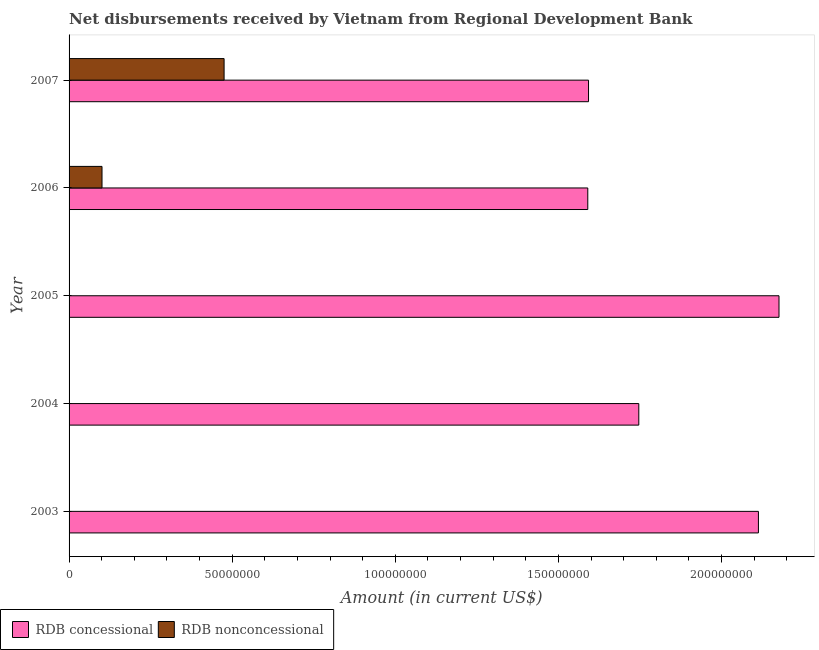How many bars are there on the 1st tick from the bottom?
Your response must be concise. 1. In how many cases, is the number of bars for a given year not equal to the number of legend labels?
Give a very brief answer. 3. What is the net concessional disbursements from rdb in 2003?
Provide a succinct answer. 2.11e+08. Across all years, what is the maximum net non concessional disbursements from rdb?
Make the answer very short. 4.75e+07. Across all years, what is the minimum net concessional disbursements from rdb?
Provide a short and direct response. 1.59e+08. In which year was the net non concessional disbursements from rdb maximum?
Your answer should be compact. 2007. What is the total net non concessional disbursements from rdb in the graph?
Make the answer very short. 5.76e+07. What is the difference between the net concessional disbursements from rdb in 2004 and that in 2007?
Make the answer very short. 1.54e+07. What is the difference between the net non concessional disbursements from rdb in 2005 and the net concessional disbursements from rdb in 2007?
Your response must be concise. -1.59e+08. What is the average net concessional disbursements from rdb per year?
Provide a succinct answer. 1.84e+08. In the year 2006, what is the difference between the net concessional disbursements from rdb and net non concessional disbursements from rdb?
Make the answer very short. 1.49e+08. What is the ratio of the net non concessional disbursements from rdb in 2006 to that in 2007?
Your answer should be very brief. 0.21. Is the net concessional disbursements from rdb in 2003 less than that in 2006?
Your answer should be compact. No. What is the difference between the highest and the second highest net concessional disbursements from rdb?
Provide a succinct answer. 6.31e+06. What is the difference between the highest and the lowest net non concessional disbursements from rdb?
Keep it short and to the point. 4.75e+07. In how many years, is the net non concessional disbursements from rdb greater than the average net non concessional disbursements from rdb taken over all years?
Give a very brief answer. 1. Is the sum of the net concessional disbursements from rdb in 2004 and 2005 greater than the maximum net non concessional disbursements from rdb across all years?
Your answer should be compact. Yes. How many bars are there?
Provide a succinct answer. 7. Are all the bars in the graph horizontal?
Offer a very short reply. Yes. Does the graph contain grids?
Your response must be concise. No. How are the legend labels stacked?
Your answer should be very brief. Horizontal. What is the title of the graph?
Provide a succinct answer. Net disbursements received by Vietnam from Regional Development Bank. Does "Nonresident" appear as one of the legend labels in the graph?
Provide a succinct answer. No. What is the label or title of the X-axis?
Provide a succinct answer. Amount (in current US$). What is the Amount (in current US$) of RDB concessional in 2003?
Offer a terse response. 2.11e+08. What is the Amount (in current US$) of RDB nonconcessional in 2003?
Your answer should be compact. 0. What is the Amount (in current US$) in RDB concessional in 2004?
Ensure brevity in your answer.  1.75e+08. What is the Amount (in current US$) of RDB nonconcessional in 2004?
Make the answer very short. 0. What is the Amount (in current US$) of RDB concessional in 2005?
Your answer should be very brief. 2.18e+08. What is the Amount (in current US$) in RDB concessional in 2006?
Your answer should be very brief. 1.59e+08. What is the Amount (in current US$) of RDB nonconcessional in 2006?
Provide a succinct answer. 1.01e+07. What is the Amount (in current US$) in RDB concessional in 2007?
Make the answer very short. 1.59e+08. What is the Amount (in current US$) of RDB nonconcessional in 2007?
Provide a short and direct response. 4.75e+07. Across all years, what is the maximum Amount (in current US$) in RDB concessional?
Give a very brief answer. 2.18e+08. Across all years, what is the maximum Amount (in current US$) of RDB nonconcessional?
Provide a succinct answer. 4.75e+07. Across all years, what is the minimum Amount (in current US$) of RDB concessional?
Offer a very short reply. 1.59e+08. Across all years, what is the minimum Amount (in current US$) in RDB nonconcessional?
Keep it short and to the point. 0. What is the total Amount (in current US$) of RDB concessional in the graph?
Provide a short and direct response. 9.22e+08. What is the total Amount (in current US$) in RDB nonconcessional in the graph?
Offer a terse response. 5.76e+07. What is the difference between the Amount (in current US$) in RDB concessional in 2003 and that in 2004?
Your answer should be compact. 3.67e+07. What is the difference between the Amount (in current US$) of RDB concessional in 2003 and that in 2005?
Offer a very short reply. -6.31e+06. What is the difference between the Amount (in current US$) in RDB concessional in 2003 and that in 2006?
Offer a terse response. 5.23e+07. What is the difference between the Amount (in current US$) of RDB concessional in 2003 and that in 2007?
Keep it short and to the point. 5.21e+07. What is the difference between the Amount (in current US$) of RDB concessional in 2004 and that in 2005?
Make the answer very short. -4.30e+07. What is the difference between the Amount (in current US$) in RDB concessional in 2004 and that in 2006?
Ensure brevity in your answer.  1.56e+07. What is the difference between the Amount (in current US$) in RDB concessional in 2004 and that in 2007?
Provide a succinct answer. 1.54e+07. What is the difference between the Amount (in current US$) of RDB concessional in 2005 and that in 2006?
Your answer should be compact. 5.86e+07. What is the difference between the Amount (in current US$) in RDB concessional in 2005 and that in 2007?
Provide a succinct answer. 5.84e+07. What is the difference between the Amount (in current US$) of RDB concessional in 2006 and that in 2007?
Your response must be concise. -2.31e+05. What is the difference between the Amount (in current US$) in RDB nonconcessional in 2006 and that in 2007?
Give a very brief answer. -3.74e+07. What is the difference between the Amount (in current US$) in RDB concessional in 2003 and the Amount (in current US$) in RDB nonconcessional in 2006?
Provide a succinct answer. 2.01e+08. What is the difference between the Amount (in current US$) in RDB concessional in 2003 and the Amount (in current US$) in RDB nonconcessional in 2007?
Provide a succinct answer. 1.64e+08. What is the difference between the Amount (in current US$) in RDB concessional in 2004 and the Amount (in current US$) in RDB nonconcessional in 2006?
Your answer should be very brief. 1.65e+08. What is the difference between the Amount (in current US$) of RDB concessional in 2004 and the Amount (in current US$) of RDB nonconcessional in 2007?
Offer a very short reply. 1.27e+08. What is the difference between the Amount (in current US$) in RDB concessional in 2005 and the Amount (in current US$) in RDB nonconcessional in 2006?
Offer a terse response. 2.08e+08. What is the difference between the Amount (in current US$) in RDB concessional in 2005 and the Amount (in current US$) in RDB nonconcessional in 2007?
Make the answer very short. 1.70e+08. What is the difference between the Amount (in current US$) in RDB concessional in 2006 and the Amount (in current US$) in RDB nonconcessional in 2007?
Your answer should be compact. 1.11e+08. What is the average Amount (in current US$) of RDB concessional per year?
Provide a short and direct response. 1.84e+08. What is the average Amount (in current US$) in RDB nonconcessional per year?
Give a very brief answer. 1.15e+07. In the year 2006, what is the difference between the Amount (in current US$) of RDB concessional and Amount (in current US$) of RDB nonconcessional?
Provide a short and direct response. 1.49e+08. In the year 2007, what is the difference between the Amount (in current US$) of RDB concessional and Amount (in current US$) of RDB nonconcessional?
Offer a terse response. 1.12e+08. What is the ratio of the Amount (in current US$) of RDB concessional in 2003 to that in 2004?
Give a very brief answer. 1.21. What is the ratio of the Amount (in current US$) in RDB concessional in 2003 to that in 2006?
Give a very brief answer. 1.33. What is the ratio of the Amount (in current US$) of RDB concessional in 2003 to that in 2007?
Ensure brevity in your answer.  1.33. What is the ratio of the Amount (in current US$) in RDB concessional in 2004 to that in 2005?
Offer a terse response. 0.8. What is the ratio of the Amount (in current US$) of RDB concessional in 2004 to that in 2006?
Offer a very short reply. 1.1. What is the ratio of the Amount (in current US$) in RDB concessional in 2004 to that in 2007?
Keep it short and to the point. 1.1. What is the ratio of the Amount (in current US$) in RDB concessional in 2005 to that in 2006?
Give a very brief answer. 1.37. What is the ratio of the Amount (in current US$) of RDB concessional in 2005 to that in 2007?
Your answer should be very brief. 1.37. What is the ratio of the Amount (in current US$) in RDB nonconcessional in 2006 to that in 2007?
Provide a succinct answer. 0.21. What is the difference between the highest and the second highest Amount (in current US$) in RDB concessional?
Keep it short and to the point. 6.31e+06. What is the difference between the highest and the lowest Amount (in current US$) in RDB concessional?
Make the answer very short. 5.86e+07. What is the difference between the highest and the lowest Amount (in current US$) of RDB nonconcessional?
Ensure brevity in your answer.  4.75e+07. 